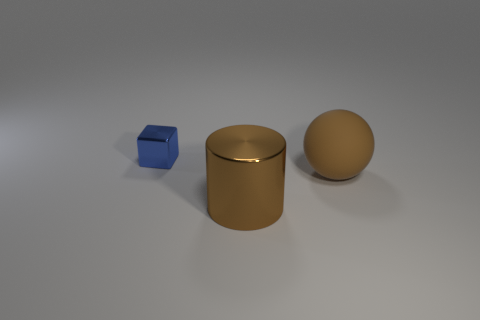Are there fewer blue shiny objects right of the brown shiny thing than cylinders to the right of the brown rubber object?
Ensure brevity in your answer.  No. Are there fewer large brown objects that are in front of the cylinder than large cyan objects?
Keep it short and to the point. No. What material is the big object that is to the left of the big brown thing that is behind the metal object that is in front of the blue metallic object?
Make the answer very short. Metal. What number of things are metal objects that are to the left of the metallic cylinder or objects that are right of the small blue shiny object?
Your answer should be compact. 3. What number of metal objects are big brown cylinders or small spheres?
Provide a succinct answer. 1. There is a brown object that is the same material as the blue thing; what shape is it?
Your answer should be compact. Cylinder. What number of other small shiny objects have the same shape as the small object?
Make the answer very short. 0. There is a metallic object in front of the tiny metallic thing; does it have the same shape as the small thing behind the large ball?
Offer a terse response. No. What number of things are tiny blue cubes or shiny things that are in front of the brown ball?
Offer a terse response. 2. What is the shape of the other big thing that is the same color as the large metal thing?
Keep it short and to the point. Sphere. 